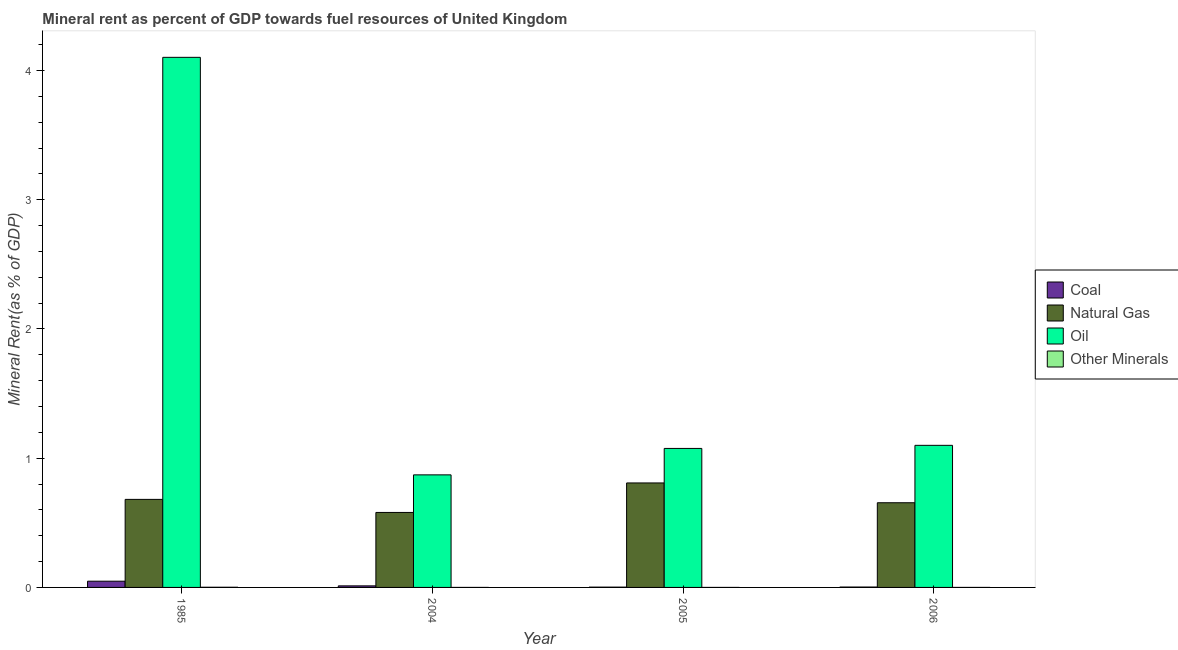How many bars are there on the 4th tick from the right?
Your response must be concise. 4. What is the coal rent in 2005?
Your answer should be very brief. 0. Across all years, what is the maximum oil rent?
Keep it short and to the point. 4.1. Across all years, what is the minimum natural gas rent?
Provide a short and direct response. 0.58. In which year was the natural gas rent minimum?
Your response must be concise. 2004. What is the total coal rent in the graph?
Offer a terse response. 0.07. What is the difference between the natural gas rent in 1985 and that in 2004?
Make the answer very short. 0.1. What is the difference between the  rent of other minerals in 1985 and the natural gas rent in 2004?
Make the answer very short. 0. What is the average natural gas rent per year?
Offer a terse response. 0.68. In the year 2005, what is the difference between the oil rent and  rent of other minerals?
Provide a short and direct response. 0. In how many years, is the coal rent greater than 1.6 %?
Make the answer very short. 0. What is the ratio of the oil rent in 1985 to that in 2004?
Offer a terse response. 4.71. Is the natural gas rent in 1985 less than that in 2005?
Provide a short and direct response. Yes. What is the difference between the highest and the second highest coal rent?
Keep it short and to the point. 0.04. What is the difference between the highest and the lowest natural gas rent?
Ensure brevity in your answer.  0.23. Is the sum of the natural gas rent in 2005 and 2006 greater than the maximum oil rent across all years?
Offer a terse response. Yes. What does the 3rd bar from the left in 2006 represents?
Give a very brief answer. Oil. What does the 4th bar from the right in 2004 represents?
Keep it short and to the point. Coal. Are all the bars in the graph horizontal?
Ensure brevity in your answer.  No. Does the graph contain grids?
Your answer should be very brief. No. Where does the legend appear in the graph?
Make the answer very short. Center right. How many legend labels are there?
Ensure brevity in your answer.  4. How are the legend labels stacked?
Provide a succinct answer. Vertical. What is the title of the graph?
Provide a succinct answer. Mineral rent as percent of GDP towards fuel resources of United Kingdom. What is the label or title of the X-axis?
Ensure brevity in your answer.  Year. What is the label or title of the Y-axis?
Keep it short and to the point. Mineral Rent(as % of GDP). What is the Mineral Rent(as % of GDP) of Coal in 1985?
Make the answer very short. 0.05. What is the Mineral Rent(as % of GDP) in Natural Gas in 1985?
Give a very brief answer. 0.68. What is the Mineral Rent(as % of GDP) in Oil in 1985?
Offer a very short reply. 4.1. What is the Mineral Rent(as % of GDP) in Other Minerals in 1985?
Give a very brief answer. 0. What is the Mineral Rent(as % of GDP) in Coal in 2004?
Give a very brief answer. 0.01. What is the Mineral Rent(as % of GDP) of Natural Gas in 2004?
Make the answer very short. 0.58. What is the Mineral Rent(as % of GDP) of Oil in 2004?
Give a very brief answer. 0.87. What is the Mineral Rent(as % of GDP) in Other Minerals in 2004?
Your response must be concise. 6.19596915094659e-6. What is the Mineral Rent(as % of GDP) in Coal in 2005?
Keep it short and to the point. 0. What is the Mineral Rent(as % of GDP) of Natural Gas in 2005?
Keep it short and to the point. 0.81. What is the Mineral Rent(as % of GDP) in Oil in 2005?
Make the answer very short. 1.08. What is the Mineral Rent(as % of GDP) in Other Minerals in 2005?
Your answer should be compact. 7.34291393954371e-6. What is the Mineral Rent(as % of GDP) in Coal in 2006?
Your response must be concise. 0. What is the Mineral Rent(as % of GDP) in Natural Gas in 2006?
Offer a very short reply. 0.66. What is the Mineral Rent(as % of GDP) in Oil in 2006?
Provide a short and direct response. 1.1. What is the Mineral Rent(as % of GDP) in Other Minerals in 2006?
Your response must be concise. 1.26189468360093e-5. Across all years, what is the maximum Mineral Rent(as % of GDP) in Coal?
Your answer should be compact. 0.05. Across all years, what is the maximum Mineral Rent(as % of GDP) of Natural Gas?
Make the answer very short. 0.81. Across all years, what is the maximum Mineral Rent(as % of GDP) in Oil?
Keep it short and to the point. 4.1. Across all years, what is the maximum Mineral Rent(as % of GDP) of Other Minerals?
Provide a succinct answer. 0. Across all years, what is the minimum Mineral Rent(as % of GDP) of Coal?
Give a very brief answer. 0. Across all years, what is the minimum Mineral Rent(as % of GDP) of Natural Gas?
Your response must be concise. 0.58. Across all years, what is the minimum Mineral Rent(as % of GDP) in Oil?
Provide a succinct answer. 0.87. Across all years, what is the minimum Mineral Rent(as % of GDP) of Other Minerals?
Keep it short and to the point. 6.19596915094659e-6. What is the total Mineral Rent(as % of GDP) in Coal in the graph?
Give a very brief answer. 0.07. What is the total Mineral Rent(as % of GDP) of Natural Gas in the graph?
Ensure brevity in your answer.  2.73. What is the total Mineral Rent(as % of GDP) of Oil in the graph?
Ensure brevity in your answer.  7.15. What is the total Mineral Rent(as % of GDP) of Other Minerals in the graph?
Provide a short and direct response. 0. What is the difference between the Mineral Rent(as % of GDP) in Coal in 1985 and that in 2004?
Offer a very short reply. 0.04. What is the difference between the Mineral Rent(as % of GDP) in Natural Gas in 1985 and that in 2004?
Ensure brevity in your answer.  0.1. What is the difference between the Mineral Rent(as % of GDP) of Oil in 1985 and that in 2004?
Offer a terse response. 3.23. What is the difference between the Mineral Rent(as % of GDP) in Other Minerals in 1985 and that in 2004?
Your answer should be compact. 0. What is the difference between the Mineral Rent(as % of GDP) in Coal in 1985 and that in 2005?
Provide a succinct answer. 0.05. What is the difference between the Mineral Rent(as % of GDP) in Natural Gas in 1985 and that in 2005?
Your answer should be very brief. -0.13. What is the difference between the Mineral Rent(as % of GDP) in Oil in 1985 and that in 2005?
Your response must be concise. 3.03. What is the difference between the Mineral Rent(as % of GDP) of Other Minerals in 1985 and that in 2005?
Keep it short and to the point. 0. What is the difference between the Mineral Rent(as % of GDP) in Coal in 1985 and that in 2006?
Ensure brevity in your answer.  0.05. What is the difference between the Mineral Rent(as % of GDP) in Natural Gas in 1985 and that in 2006?
Offer a very short reply. 0.03. What is the difference between the Mineral Rent(as % of GDP) of Oil in 1985 and that in 2006?
Provide a succinct answer. 3. What is the difference between the Mineral Rent(as % of GDP) in Other Minerals in 1985 and that in 2006?
Give a very brief answer. 0. What is the difference between the Mineral Rent(as % of GDP) in Coal in 2004 and that in 2005?
Your response must be concise. 0.01. What is the difference between the Mineral Rent(as % of GDP) in Natural Gas in 2004 and that in 2005?
Give a very brief answer. -0.23. What is the difference between the Mineral Rent(as % of GDP) in Oil in 2004 and that in 2005?
Offer a terse response. -0.2. What is the difference between the Mineral Rent(as % of GDP) of Coal in 2004 and that in 2006?
Provide a succinct answer. 0.01. What is the difference between the Mineral Rent(as % of GDP) of Natural Gas in 2004 and that in 2006?
Provide a succinct answer. -0.07. What is the difference between the Mineral Rent(as % of GDP) in Oil in 2004 and that in 2006?
Make the answer very short. -0.23. What is the difference between the Mineral Rent(as % of GDP) in Other Minerals in 2004 and that in 2006?
Make the answer very short. -0. What is the difference between the Mineral Rent(as % of GDP) in Coal in 2005 and that in 2006?
Your answer should be compact. -0. What is the difference between the Mineral Rent(as % of GDP) in Natural Gas in 2005 and that in 2006?
Ensure brevity in your answer.  0.15. What is the difference between the Mineral Rent(as % of GDP) of Oil in 2005 and that in 2006?
Provide a short and direct response. -0.02. What is the difference between the Mineral Rent(as % of GDP) in Other Minerals in 2005 and that in 2006?
Make the answer very short. -0. What is the difference between the Mineral Rent(as % of GDP) of Coal in 1985 and the Mineral Rent(as % of GDP) of Natural Gas in 2004?
Make the answer very short. -0.53. What is the difference between the Mineral Rent(as % of GDP) of Coal in 1985 and the Mineral Rent(as % of GDP) of Oil in 2004?
Provide a succinct answer. -0.82. What is the difference between the Mineral Rent(as % of GDP) of Coal in 1985 and the Mineral Rent(as % of GDP) of Other Minerals in 2004?
Your answer should be very brief. 0.05. What is the difference between the Mineral Rent(as % of GDP) of Natural Gas in 1985 and the Mineral Rent(as % of GDP) of Oil in 2004?
Your answer should be very brief. -0.19. What is the difference between the Mineral Rent(as % of GDP) in Natural Gas in 1985 and the Mineral Rent(as % of GDP) in Other Minerals in 2004?
Your answer should be very brief. 0.68. What is the difference between the Mineral Rent(as % of GDP) in Oil in 1985 and the Mineral Rent(as % of GDP) in Other Minerals in 2004?
Give a very brief answer. 4.1. What is the difference between the Mineral Rent(as % of GDP) in Coal in 1985 and the Mineral Rent(as % of GDP) in Natural Gas in 2005?
Offer a very short reply. -0.76. What is the difference between the Mineral Rent(as % of GDP) of Coal in 1985 and the Mineral Rent(as % of GDP) of Oil in 2005?
Make the answer very short. -1.03. What is the difference between the Mineral Rent(as % of GDP) in Coal in 1985 and the Mineral Rent(as % of GDP) in Other Minerals in 2005?
Keep it short and to the point. 0.05. What is the difference between the Mineral Rent(as % of GDP) in Natural Gas in 1985 and the Mineral Rent(as % of GDP) in Oil in 2005?
Offer a very short reply. -0.39. What is the difference between the Mineral Rent(as % of GDP) of Natural Gas in 1985 and the Mineral Rent(as % of GDP) of Other Minerals in 2005?
Your answer should be very brief. 0.68. What is the difference between the Mineral Rent(as % of GDP) of Oil in 1985 and the Mineral Rent(as % of GDP) of Other Minerals in 2005?
Keep it short and to the point. 4.1. What is the difference between the Mineral Rent(as % of GDP) of Coal in 1985 and the Mineral Rent(as % of GDP) of Natural Gas in 2006?
Provide a succinct answer. -0.61. What is the difference between the Mineral Rent(as % of GDP) in Coal in 1985 and the Mineral Rent(as % of GDP) in Oil in 2006?
Provide a short and direct response. -1.05. What is the difference between the Mineral Rent(as % of GDP) in Coal in 1985 and the Mineral Rent(as % of GDP) in Other Minerals in 2006?
Your response must be concise. 0.05. What is the difference between the Mineral Rent(as % of GDP) of Natural Gas in 1985 and the Mineral Rent(as % of GDP) of Oil in 2006?
Your response must be concise. -0.42. What is the difference between the Mineral Rent(as % of GDP) in Natural Gas in 1985 and the Mineral Rent(as % of GDP) in Other Minerals in 2006?
Offer a terse response. 0.68. What is the difference between the Mineral Rent(as % of GDP) of Oil in 1985 and the Mineral Rent(as % of GDP) of Other Minerals in 2006?
Offer a very short reply. 4.1. What is the difference between the Mineral Rent(as % of GDP) in Coal in 2004 and the Mineral Rent(as % of GDP) in Natural Gas in 2005?
Give a very brief answer. -0.8. What is the difference between the Mineral Rent(as % of GDP) of Coal in 2004 and the Mineral Rent(as % of GDP) of Oil in 2005?
Your answer should be compact. -1.06. What is the difference between the Mineral Rent(as % of GDP) of Coal in 2004 and the Mineral Rent(as % of GDP) of Other Minerals in 2005?
Your answer should be very brief. 0.01. What is the difference between the Mineral Rent(as % of GDP) in Natural Gas in 2004 and the Mineral Rent(as % of GDP) in Oil in 2005?
Your answer should be compact. -0.5. What is the difference between the Mineral Rent(as % of GDP) in Natural Gas in 2004 and the Mineral Rent(as % of GDP) in Other Minerals in 2005?
Keep it short and to the point. 0.58. What is the difference between the Mineral Rent(as % of GDP) of Oil in 2004 and the Mineral Rent(as % of GDP) of Other Minerals in 2005?
Ensure brevity in your answer.  0.87. What is the difference between the Mineral Rent(as % of GDP) of Coal in 2004 and the Mineral Rent(as % of GDP) of Natural Gas in 2006?
Provide a succinct answer. -0.64. What is the difference between the Mineral Rent(as % of GDP) of Coal in 2004 and the Mineral Rent(as % of GDP) of Oil in 2006?
Make the answer very short. -1.09. What is the difference between the Mineral Rent(as % of GDP) in Coal in 2004 and the Mineral Rent(as % of GDP) in Other Minerals in 2006?
Your response must be concise. 0.01. What is the difference between the Mineral Rent(as % of GDP) of Natural Gas in 2004 and the Mineral Rent(as % of GDP) of Oil in 2006?
Keep it short and to the point. -0.52. What is the difference between the Mineral Rent(as % of GDP) in Natural Gas in 2004 and the Mineral Rent(as % of GDP) in Other Minerals in 2006?
Make the answer very short. 0.58. What is the difference between the Mineral Rent(as % of GDP) in Oil in 2004 and the Mineral Rent(as % of GDP) in Other Minerals in 2006?
Offer a very short reply. 0.87. What is the difference between the Mineral Rent(as % of GDP) of Coal in 2005 and the Mineral Rent(as % of GDP) of Natural Gas in 2006?
Keep it short and to the point. -0.65. What is the difference between the Mineral Rent(as % of GDP) of Coal in 2005 and the Mineral Rent(as % of GDP) of Oil in 2006?
Provide a succinct answer. -1.1. What is the difference between the Mineral Rent(as % of GDP) in Coal in 2005 and the Mineral Rent(as % of GDP) in Other Minerals in 2006?
Provide a short and direct response. 0. What is the difference between the Mineral Rent(as % of GDP) of Natural Gas in 2005 and the Mineral Rent(as % of GDP) of Oil in 2006?
Ensure brevity in your answer.  -0.29. What is the difference between the Mineral Rent(as % of GDP) of Natural Gas in 2005 and the Mineral Rent(as % of GDP) of Other Minerals in 2006?
Provide a succinct answer. 0.81. What is the difference between the Mineral Rent(as % of GDP) in Oil in 2005 and the Mineral Rent(as % of GDP) in Other Minerals in 2006?
Make the answer very short. 1.08. What is the average Mineral Rent(as % of GDP) of Coal per year?
Your response must be concise. 0.02. What is the average Mineral Rent(as % of GDP) in Natural Gas per year?
Provide a succinct answer. 0.68. What is the average Mineral Rent(as % of GDP) in Oil per year?
Your response must be concise. 1.79. What is the average Mineral Rent(as % of GDP) of Other Minerals per year?
Keep it short and to the point. 0. In the year 1985, what is the difference between the Mineral Rent(as % of GDP) of Coal and Mineral Rent(as % of GDP) of Natural Gas?
Offer a very short reply. -0.63. In the year 1985, what is the difference between the Mineral Rent(as % of GDP) of Coal and Mineral Rent(as % of GDP) of Oil?
Provide a short and direct response. -4.05. In the year 1985, what is the difference between the Mineral Rent(as % of GDP) in Coal and Mineral Rent(as % of GDP) in Other Minerals?
Your answer should be compact. 0.05. In the year 1985, what is the difference between the Mineral Rent(as % of GDP) in Natural Gas and Mineral Rent(as % of GDP) in Oil?
Provide a short and direct response. -3.42. In the year 1985, what is the difference between the Mineral Rent(as % of GDP) of Natural Gas and Mineral Rent(as % of GDP) of Other Minerals?
Make the answer very short. 0.68. In the year 1985, what is the difference between the Mineral Rent(as % of GDP) in Oil and Mineral Rent(as % of GDP) in Other Minerals?
Your response must be concise. 4.1. In the year 2004, what is the difference between the Mineral Rent(as % of GDP) in Coal and Mineral Rent(as % of GDP) in Natural Gas?
Provide a succinct answer. -0.57. In the year 2004, what is the difference between the Mineral Rent(as % of GDP) in Coal and Mineral Rent(as % of GDP) in Oil?
Give a very brief answer. -0.86. In the year 2004, what is the difference between the Mineral Rent(as % of GDP) of Coal and Mineral Rent(as % of GDP) of Other Minerals?
Offer a terse response. 0.01. In the year 2004, what is the difference between the Mineral Rent(as % of GDP) in Natural Gas and Mineral Rent(as % of GDP) in Oil?
Your response must be concise. -0.29. In the year 2004, what is the difference between the Mineral Rent(as % of GDP) in Natural Gas and Mineral Rent(as % of GDP) in Other Minerals?
Your answer should be compact. 0.58. In the year 2004, what is the difference between the Mineral Rent(as % of GDP) of Oil and Mineral Rent(as % of GDP) of Other Minerals?
Provide a short and direct response. 0.87. In the year 2005, what is the difference between the Mineral Rent(as % of GDP) in Coal and Mineral Rent(as % of GDP) in Natural Gas?
Give a very brief answer. -0.81. In the year 2005, what is the difference between the Mineral Rent(as % of GDP) in Coal and Mineral Rent(as % of GDP) in Oil?
Your answer should be very brief. -1.07. In the year 2005, what is the difference between the Mineral Rent(as % of GDP) in Coal and Mineral Rent(as % of GDP) in Other Minerals?
Make the answer very short. 0. In the year 2005, what is the difference between the Mineral Rent(as % of GDP) of Natural Gas and Mineral Rent(as % of GDP) of Oil?
Your answer should be very brief. -0.27. In the year 2005, what is the difference between the Mineral Rent(as % of GDP) in Natural Gas and Mineral Rent(as % of GDP) in Other Minerals?
Your answer should be very brief. 0.81. In the year 2005, what is the difference between the Mineral Rent(as % of GDP) in Oil and Mineral Rent(as % of GDP) in Other Minerals?
Your response must be concise. 1.08. In the year 2006, what is the difference between the Mineral Rent(as % of GDP) in Coal and Mineral Rent(as % of GDP) in Natural Gas?
Keep it short and to the point. -0.65. In the year 2006, what is the difference between the Mineral Rent(as % of GDP) in Coal and Mineral Rent(as % of GDP) in Oil?
Your answer should be very brief. -1.1. In the year 2006, what is the difference between the Mineral Rent(as % of GDP) in Coal and Mineral Rent(as % of GDP) in Other Minerals?
Your answer should be compact. 0. In the year 2006, what is the difference between the Mineral Rent(as % of GDP) in Natural Gas and Mineral Rent(as % of GDP) in Oil?
Ensure brevity in your answer.  -0.44. In the year 2006, what is the difference between the Mineral Rent(as % of GDP) of Natural Gas and Mineral Rent(as % of GDP) of Other Minerals?
Keep it short and to the point. 0.66. In the year 2006, what is the difference between the Mineral Rent(as % of GDP) of Oil and Mineral Rent(as % of GDP) of Other Minerals?
Offer a terse response. 1.1. What is the ratio of the Mineral Rent(as % of GDP) of Coal in 1985 to that in 2004?
Offer a terse response. 3.99. What is the ratio of the Mineral Rent(as % of GDP) of Natural Gas in 1985 to that in 2004?
Offer a very short reply. 1.17. What is the ratio of the Mineral Rent(as % of GDP) in Oil in 1985 to that in 2004?
Provide a short and direct response. 4.71. What is the ratio of the Mineral Rent(as % of GDP) of Other Minerals in 1985 to that in 2004?
Your response must be concise. 214.29. What is the ratio of the Mineral Rent(as % of GDP) of Coal in 1985 to that in 2005?
Provide a succinct answer. 21.31. What is the ratio of the Mineral Rent(as % of GDP) in Natural Gas in 1985 to that in 2005?
Your answer should be very brief. 0.84. What is the ratio of the Mineral Rent(as % of GDP) of Oil in 1985 to that in 2005?
Your response must be concise. 3.81. What is the ratio of the Mineral Rent(as % of GDP) in Other Minerals in 1985 to that in 2005?
Provide a short and direct response. 180.82. What is the ratio of the Mineral Rent(as % of GDP) of Coal in 1985 to that in 2006?
Offer a terse response. 15.79. What is the ratio of the Mineral Rent(as % of GDP) in Natural Gas in 1985 to that in 2006?
Your answer should be very brief. 1.04. What is the ratio of the Mineral Rent(as % of GDP) in Oil in 1985 to that in 2006?
Provide a succinct answer. 3.73. What is the ratio of the Mineral Rent(as % of GDP) in Other Minerals in 1985 to that in 2006?
Offer a terse response. 105.22. What is the ratio of the Mineral Rent(as % of GDP) of Coal in 2004 to that in 2005?
Give a very brief answer. 5.34. What is the ratio of the Mineral Rent(as % of GDP) in Natural Gas in 2004 to that in 2005?
Keep it short and to the point. 0.72. What is the ratio of the Mineral Rent(as % of GDP) in Oil in 2004 to that in 2005?
Keep it short and to the point. 0.81. What is the ratio of the Mineral Rent(as % of GDP) in Other Minerals in 2004 to that in 2005?
Your response must be concise. 0.84. What is the ratio of the Mineral Rent(as % of GDP) of Coal in 2004 to that in 2006?
Make the answer very short. 3.96. What is the ratio of the Mineral Rent(as % of GDP) of Natural Gas in 2004 to that in 2006?
Your answer should be compact. 0.89. What is the ratio of the Mineral Rent(as % of GDP) of Oil in 2004 to that in 2006?
Ensure brevity in your answer.  0.79. What is the ratio of the Mineral Rent(as % of GDP) of Other Minerals in 2004 to that in 2006?
Offer a terse response. 0.49. What is the ratio of the Mineral Rent(as % of GDP) in Coal in 2005 to that in 2006?
Your answer should be compact. 0.74. What is the ratio of the Mineral Rent(as % of GDP) of Natural Gas in 2005 to that in 2006?
Ensure brevity in your answer.  1.23. What is the ratio of the Mineral Rent(as % of GDP) in Oil in 2005 to that in 2006?
Give a very brief answer. 0.98. What is the ratio of the Mineral Rent(as % of GDP) in Other Minerals in 2005 to that in 2006?
Provide a succinct answer. 0.58. What is the difference between the highest and the second highest Mineral Rent(as % of GDP) in Coal?
Offer a terse response. 0.04. What is the difference between the highest and the second highest Mineral Rent(as % of GDP) in Natural Gas?
Your response must be concise. 0.13. What is the difference between the highest and the second highest Mineral Rent(as % of GDP) in Oil?
Keep it short and to the point. 3. What is the difference between the highest and the second highest Mineral Rent(as % of GDP) of Other Minerals?
Give a very brief answer. 0. What is the difference between the highest and the lowest Mineral Rent(as % of GDP) in Coal?
Ensure brevity in your answer.  0.05. What is the difference between the highest and the lowest Mineral Rent(as % of GDP) in Natural Gas?
Ensure brevity in your answer.  0.23. What is the difference between the highest and the lowest Mineral Rent(as % of GDP) in Oil?
Give a very brief answer. 3.23. What is the difference between the highest and the lowest Mineral Rent(as % of GDP) in Other Minerals?
Make the answer very short. 0. 